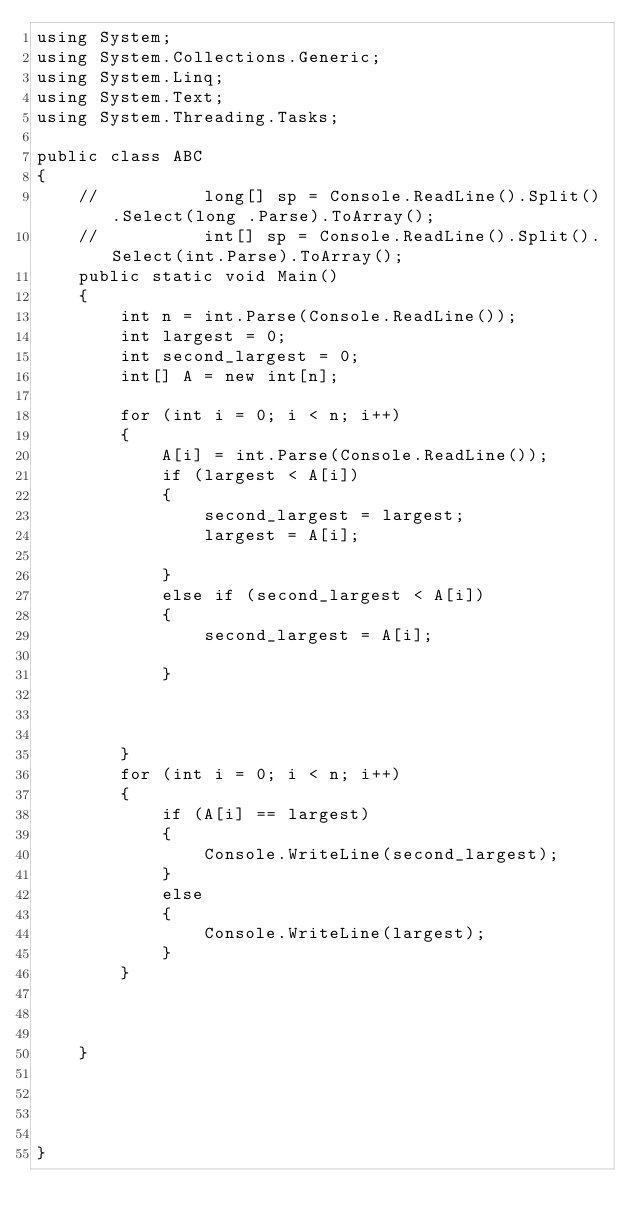Convert code to text. <code><loc_0><loc_0><loc_500><loc_500><_C#_>using System;
using System.Collections.Generic;
using System.Linq;
using System.Text;
using System.Threading.Tasks;

public class ABC
{
    //          long[] sp = Console.ReadLine().Split().Select(long .Parse).ToArray();
    //          int[] sp = Console.ReadLine().Split().Select(int.Parse).ToArray();
    public static void Main()
    {
        int n = int.Parse(Console.ReadLine());
        int largest = 0;
        int second_largest = 0;
        int[] A = new int[n];

        for (int i = 0; i < n; i++)
        {
            A[i] = int.Parse(Console.ReadLine());
            if (largest < A[i])
            {
                second_largest = largest;
                largest = A[i];

            }
            else if (second_largest < A[i])
            {
                second_largest = A[i];

            }



        }
        for (int i = 0; i < n; i++)
        {
            if (A[i] == largest)
            {
                Console.WriteLine(second_largest);
            }
            else
            {
                Console.WriteLine(largest);
            }
        }



    }




}

</code> 